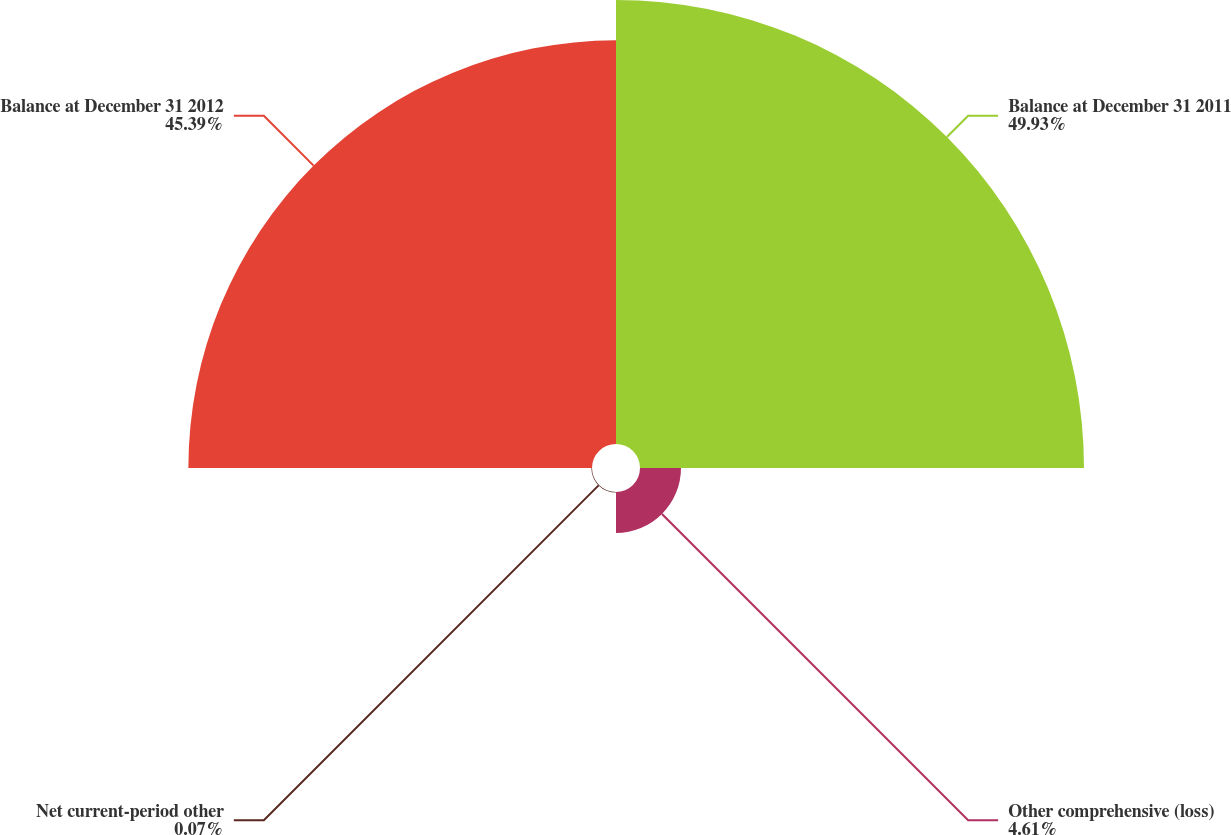Convert chart to OTSL. <chart><loc_0><loc_0><loc_500><loc_500><pie_chart><fcel>Balance at December 31 2011<fcel>Other comprehensive (loss)<fcel>Net current-period other<fcel>Balance at December 31 2012<nl><fcel>49.93%<fcel>4.61%<fcel>0.07%<fcel>45.39%<nl></chart> 